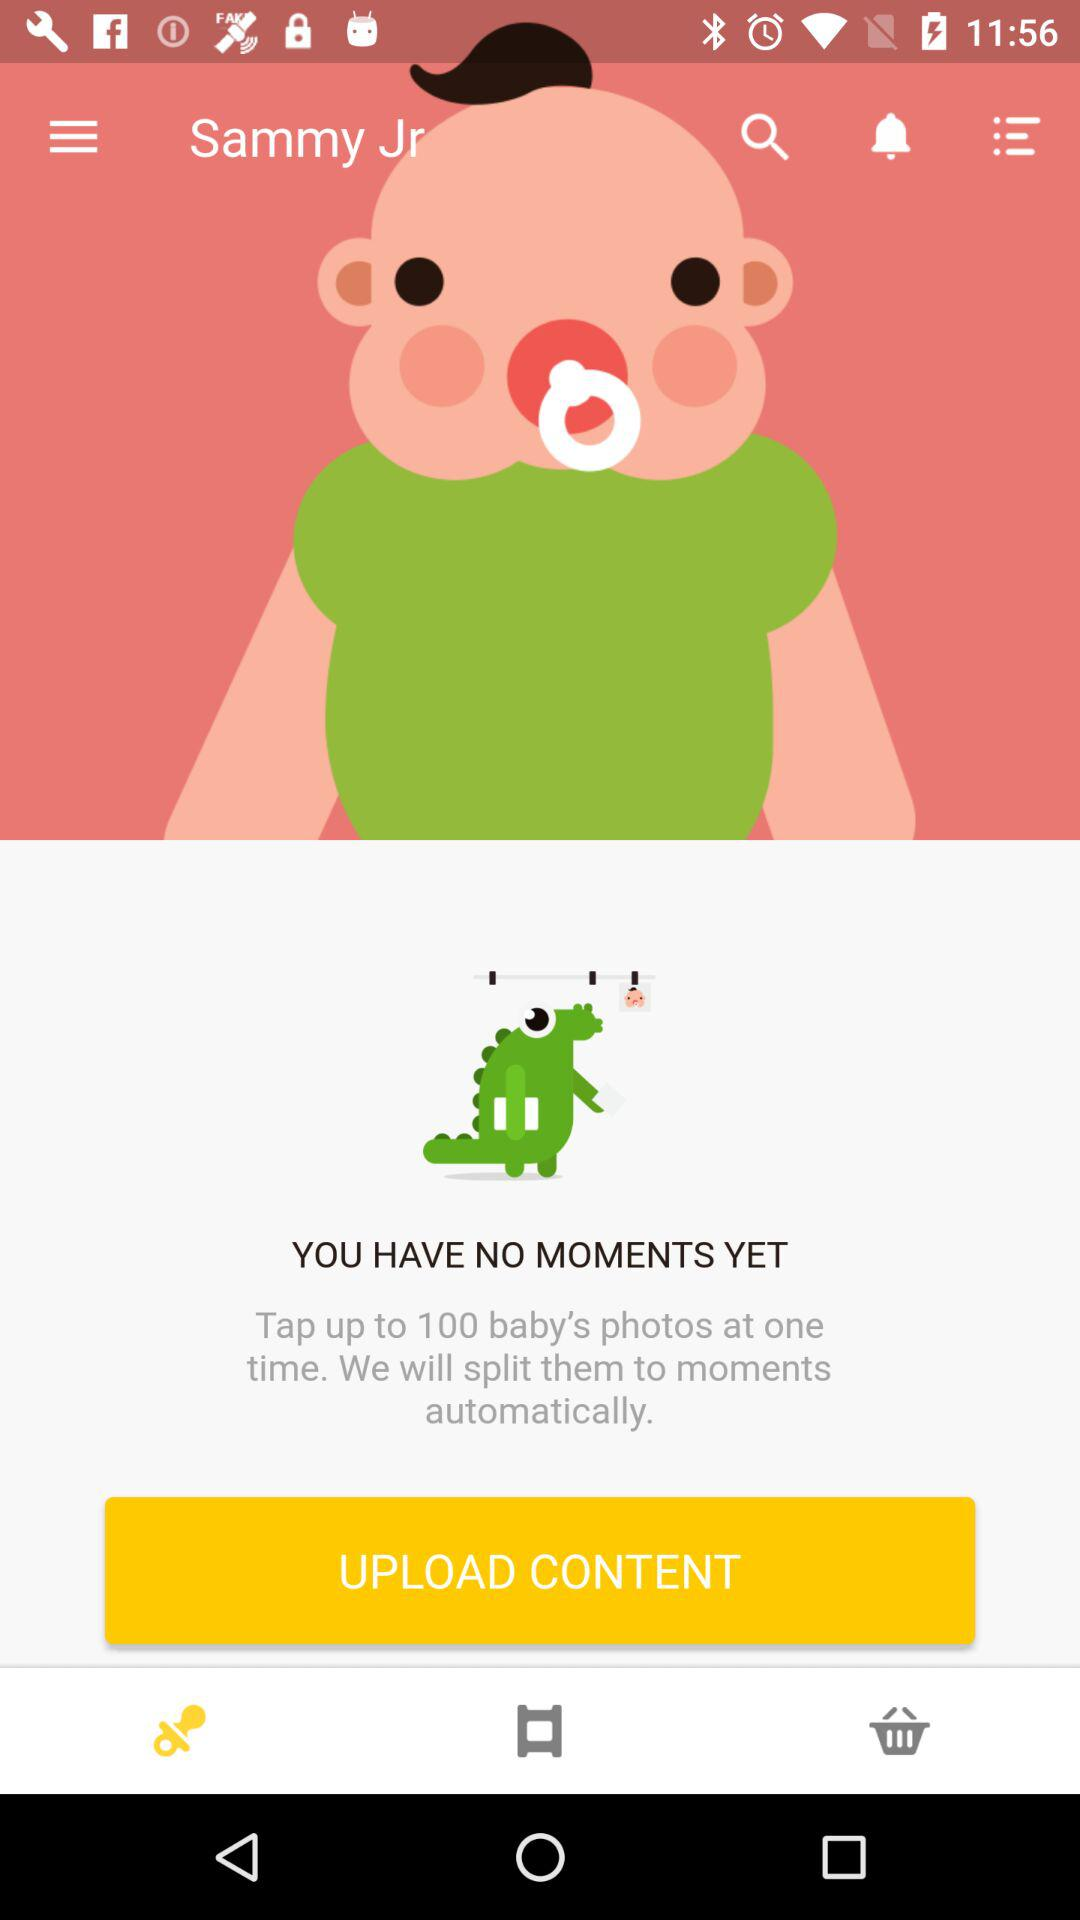How many photos can be tapped at one time? The number of photos that can be tapped at one time is up to 100. 